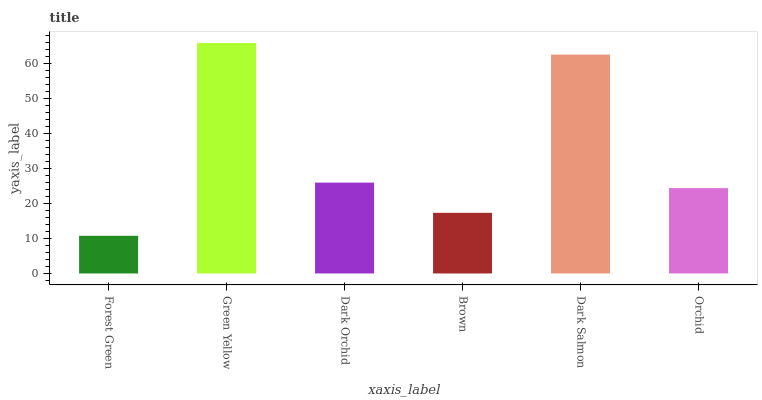Is Forest Green the minimum?
Answer yes or no. Yes. Is Green Yellow the maximum?
Answer yes or no. Yes. Is Dark Orchid the minimum?
Answer yes or no. No. Is Dark Orchid the maximum?
Answer yes or no. No. Is Green Yellow greater than Dark Orchid?
Answer yes or no. Yes. Is Dark Orchid less than Green Yellow?
Answer yes or no. Yes. Is Dark Orchid greater than Green Yellow?
Answer yes or no. No. Is Green Yellow less than Dark Orchid?
Answer yes or no. No. Is Dark Orchid the high median?
Answer yes or no. Yes. Is Orchid the low median?
Answer yes or no. Yes. Is Green Yellow the high median?
Answer yes or no. No. Is Green Yellow the low median?
Answer yes or no. No. 